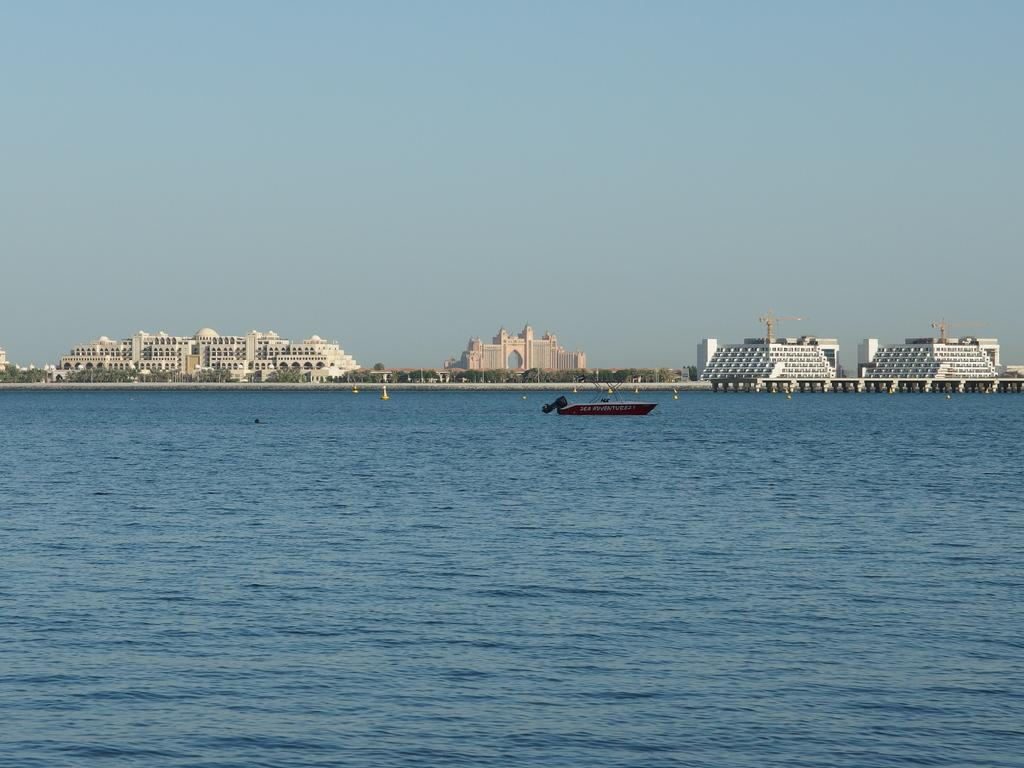What type of vehicle is in the image? There is a speed boat in the image. Where is the speed boat located? The speed boat is on the water. What can be seen in the background of the image? There are trees, buildings, and the sky visible in the background of the image. Are there any objects on the right side of the image? Yes, there are objects on the right side of the image. Can you see a hole in the speed boat in the image? There is no hole visible in the speed boat in the image. What type of bomb is being dropped from the sky in the image? There is no bomb present in the image; it features a speed boat on the water with a background of trees, buildings, and the sky. 